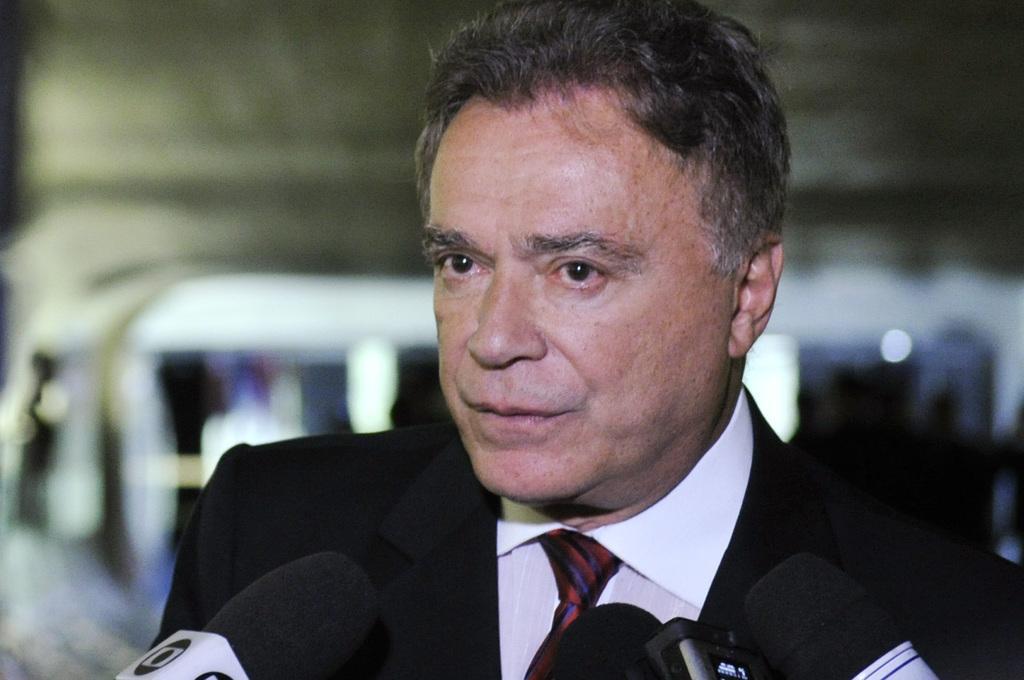In one or two sentences, can you explain what this image depicts? A man is standing wearing a suit. There are microphones in the front. The background is blurred. 